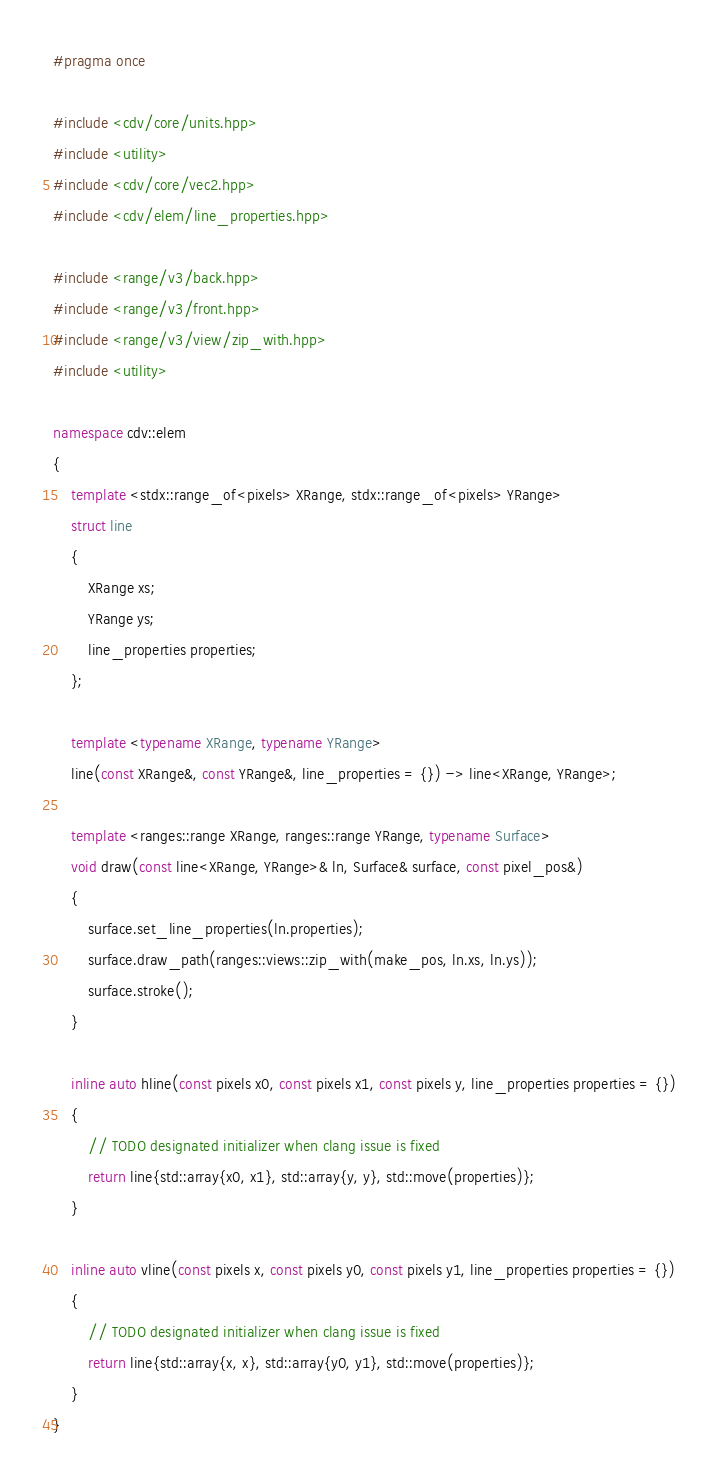Convert code to text. <code><loc_0><loc_0><loc_500><loc_500><_C++_>#pragma once

#include <cdv/core/units.hpp>
#include <utility>
#include <cdv/core/vec2.hpp>
#include <cdv/elem/line_properties.hpp>

#include <range/v3/back.hpp>
#include <range/v3/front.hpp>
#include <range/v3/view/zip_with.hpp>
#include <utility>

namespace cdv::elem
{
    template <stdx::range_of<pixels> XRange, stdx::range_of<pixels> YRange>
    struct line
    {
        XRange xs;
        YRange ys;
        line_properties properties;
    };

    template <typename XRange, typename YRange>
    line(const XRange&, const YRange&, line_properties = {}) -> line<XRange, YRange>;

    template <ranges::range XRange, ranges::range YRange, typename Surface>
    void draw(const line<XRange, YRange>& ln, Surface& surface, const pixel_pos&)
    {
        surface.set_line_properties(ln.properties);
        surface.draw_path(ranges::views::zip_with(make_pos, ln.xs, ln.ys));
        surface.stroke();
    }

    inline auto hline(const pixels x0, const pixels x1, const pixels y, line_properties properties = {})
    {
        // TODO designated initializer when clang issue is fixed
        return line{std::array{x0, x1}, std::array{y, y}, std::move(properties)};
    }

    inline auto vline(const pixels x, const pixels y0, const pixels y1, line_properties properties = {})
    {
        // TODO designated initializer when clang issue is fixed
        return line{std::array{x, x}, std::array{y0, y1}, std::move(properties)};
    }
}</code> 